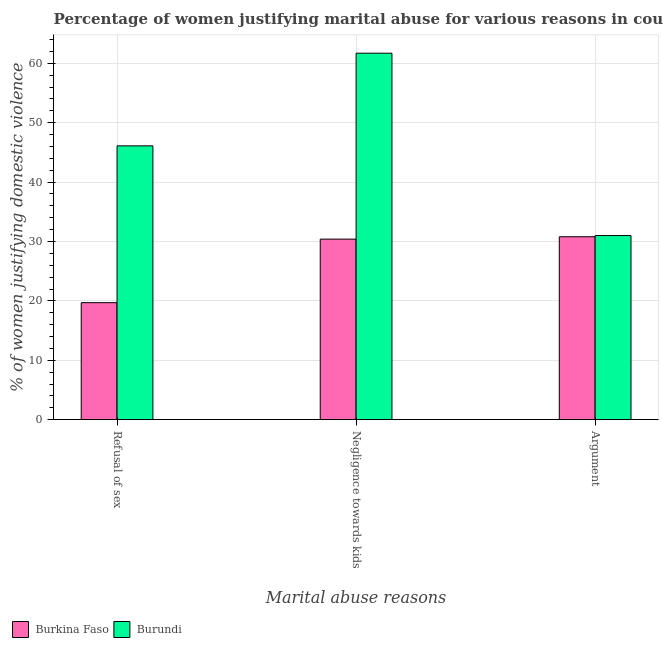How many groups of bars are there?
Offer a terse response. 3. Are the number of bars per tick equal to the number of legend labels?
Provide a succinct answer. Yes. Are the number of bars on each tick of the X-axis equal?
Keep it short and to the point. Yes. How many bars are there on the 3rd tick from the right?
Ensure brevity in your answer.  2. What is the label of the 2nd group of bars from the left?
Keep it short and to the point. Negligence towards kids. Across all countries, what is the maximum percentage of women justifying domestic violence due to arguments?
Offer a terse response. 31. Across all countries, what is the minimum percentage of women justifying domestic violence due to arguments?
Provide a succinct answer. 30.8. In which country was the percentage of women justifying domestic violence due to refusal of sex maximum?
Your response must be concise. Burundi. In which country was the percentage of women justifying domestic violence due to negligence towards kids minimum?
Give a very brief answer. Burkina Faso. What is the total percentage of women justifying domestic violence due to negligence towards kids in the graph?
Your answer should be compact. 92.1. What is the difference between the percentage of women justifying domestic violence due to arguments in Burkina Faso and that in Burundi?
Make the answer very short. -0.2. What is the average percentage of women justifying domestic violence due to negligence towards kids per country?
Offer a terse response. 46.05. What is the difference between the percentage of women justifying domestic violence due to negligence towards kids and percentage of women justifying domestic violence due to arguments in Burkina Faso?
Your answer should be very brief. -0.4. In how many countries, is the percentage of women justifying domestic violence due to refusal of sex greater than 30 %?
Provide a short and direct response. 1. What is the ratio of the percentage of women justifying domestic violence due to arguments in Burkina Faso to that in Burundi?
Give a very brief answer. 0.99. Is the percentage of women justifying domestic violence due to arguments in Burundi less than that in Burkina Faso?
Make the answer very short. No. What is the difference between the highest and the second highest percentage of women justifying domestic violence due to negligence towards kids?
Keep it short and to the point. 31.3. What is the difference between the highest and the lowest percentage of women justifying domestic violence due to refusal of sex?
Your answer should be compact. 26.4. Is the sum of the percentage of women justifying domestic violence due to arguments in Burkina Faso and Burundi greater than the maximum percentage of women justifying domestic violence due to negligence towards kids across all countries?
Ensure brevity in your answer.  Yes. What does the 1st bar from the left in Refusal of sex represents?
Ensure brevity in your answer.  Burkina Faso. What does the 1st bar from the right in Negligence towards kids represents?
Your response must be concise. Burundi. Is it the case that in every country, the sum of the percentage of women justifying domestic violence due to refusal of sex and percentage of women justifying domestic violence due to negligence towards kids is greater than the percentage of women justifying domestic violence due to arguments?
Provide a short and direct response. Yes. How many bars are there?
Your answer should be compact. 6. Does the graph contain any zero values?
Make the answer very short. No. Does the graph contain grids?
Your answer should be compact. Yes. Where does the legend appear in the graph?
Ensure brevity in your answer.  Bottom left. What is the title of the graph?
Offer a very short reply. Percentage of women justifying marital abuse for various reasons in countries in 2010. What is the label or title of the X-axis?
Your response must be concise. Marital abuse reasons. What is the label or title of the Y-axis?
Keep it short and to the point. % of women justifying domestic violence. What is the % of women justifying domestic violence of Burkina Faso in Refusal of sex?
Give a very brief answer. 19.7. What is the % of women justifying domestic violence of Burundi in Refusal of sex?
Your response must be concise. 46.1. What is the % of women justifying domestic violence in Burkina Faso in Negligence towards kids?
Offer a terse response. 30.4. What is the % of women justifying domestic violence in Burundi in Negligence towards kids?
Your response must be concise. 61.7. What is the % of women justifying domestic violence of Burkina Faso in Argument?
Your answer should be compact. 30.8. Across all Marital abuse reasons, what is the maximum % of women justifying domestic violence in Burkina Faso?
Keep it short and to the point. 30.8. Across all Marital abuse reasons, what is the maximum % of women justifying domestic violence of Burundi?
Your answer should be very brief. 61.7. Across all Marital abuse reasons, what is the minimum % of women justifying domestic violence in Burkina Faso?
Your answer should be compact. 19.7. What is the total % of women justifying domestic violence in Burkina Faso in the graph?
Keep it short and to the point. 80.9. What is the total % of women justifying domestic violence in Burundi in the graph?
Offer a very short reply. 138.8. What is the difference between the % of women justifying domestic violence in Burkina Faso in Refusal of sex and that in Negligence towards kids?
Offer a very short reply. -10.7. What is the difference between the % of women justifying domestic violence of Burundi in Refusal of sex and that in Negligence towards kids?
Your answer should be very brief. -15.6. What is the difference between the % of women justifying domestic violence in Burundi in Refusal of sex and that in Argument?
Ensure brevity in your answer.  15.1. What is the difference between the % of women justifying domestic violence in Burkina Faso in Negligence towards kids and that in Argument?
Give a very brief answer. -0.4. What is the difference between the % of women justifying domestic violence in Burundi in Negligence towards kids and that in Argument?
Provide a short and direct response. 30.7. What is the difference between the % of women justifying domestic violence in Burkina Faso in Refusal of sex and the % of women justifying domestic violence in Burundi in Negligence towards kids?
Your answer should be compact. -42. What is the average % of women justifying domestic violence of Burkina Faso per Marital abuse reasons?
Give a very brief answer. 26.97. What is the average % of women justifying domestic violence in Burundi per Marital abuse reasons?
Your answer should be compact. 46.27. What is the difference between the % of women justifying domestic violence of Burkina Faso and % of women justifying domestic violence of Burundi in Refusal of sex?
Offer a very short reply. -26.4. What is the difference between the % of women justifying domestic violence of Burkina Faso and % of women justifying domestic violence of Burundi in Negligence towards kids?
Keep it short and to the point. -31.3. What is the ratio of the % of women justifying domestic violence in Burkina Faso in Refusal of sex to that in Negligence towards kids?
Make the answer very short. 0.65. What is the ratio of the % of women justifying domestic violence in Burundi in Refusal of sex to that in Negligence towards kids?
Make the answer very short. 0.75. What is the ratio of the % of women justifying domestic violence in Burkina Faso in Refusal of sex to that in Argument?
Your answer should be very brief. 0.64. What is the ratio of the % of women justifying domestic violence of Burundi in Refusal of sex to that in Argument?
Give a very brief answer. 1.49. What is the ratio of the % of women justifying domestic violence in Burkina Faso in Negligence towards kids to that in Argument?
Give a very brief answer. 0.99. What is the ratio of the % of women justifying domestic violence in Burundi in Negligence towards kids to that in Argument?
Provide a short and direct response. 1.99. What is the difference between the highest and the second highest % of women justifying domestic violence of Burundi?
Offer a very short reply. 15.6. What is the difference between the highest and the lowest % of women justifying domestic violence of Burundi?
Give a very brief answer. 30.7. 